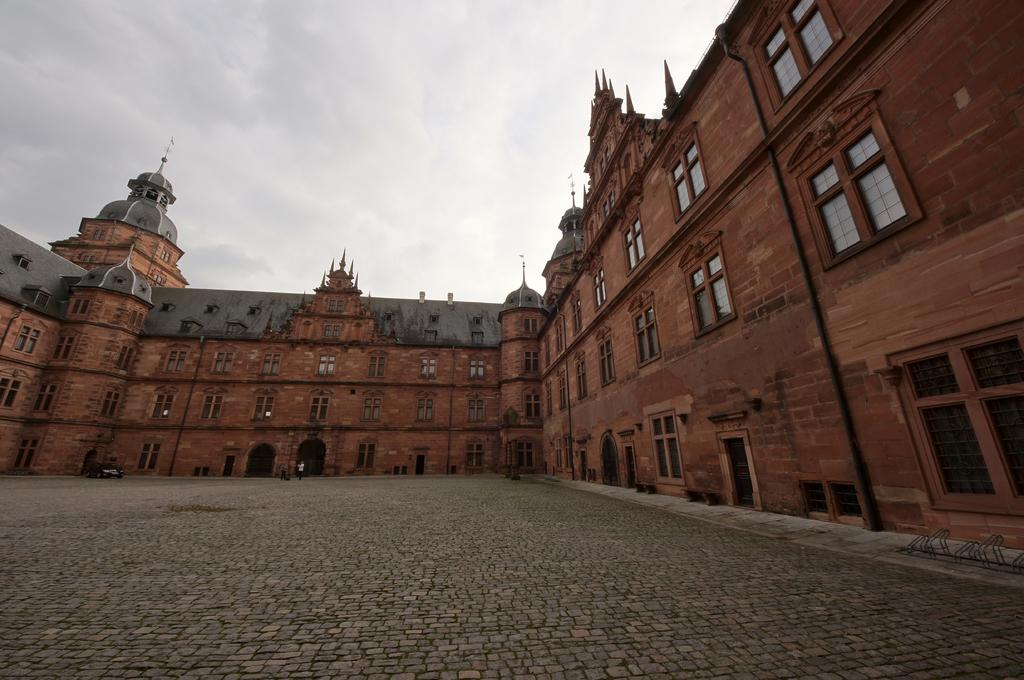What type of structure is present in the image? There is a building in the image. What type of terrain is visible in the image? There is land visible in the image. What is the condition of the sky in the image? The sky is covered with clouds. What rule is being enforced by the clouds in the image? There is no indication in the image that the clouds are enforcing any rules. 